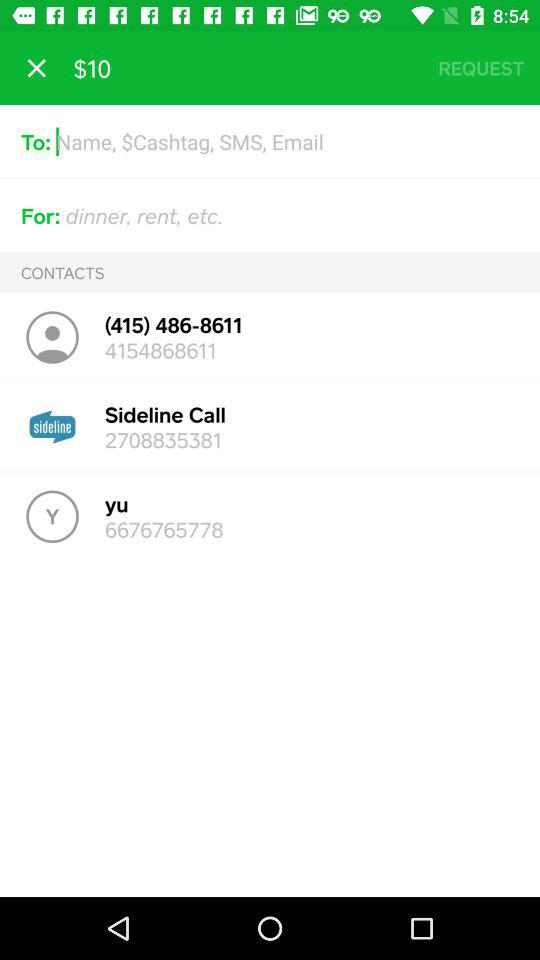How many dollars are displayed on the screen? The displayed dollar on the screen is $10. 